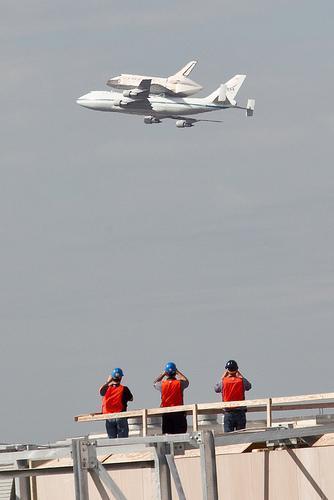How many workers are there?
Give a very brief answer. 3. 